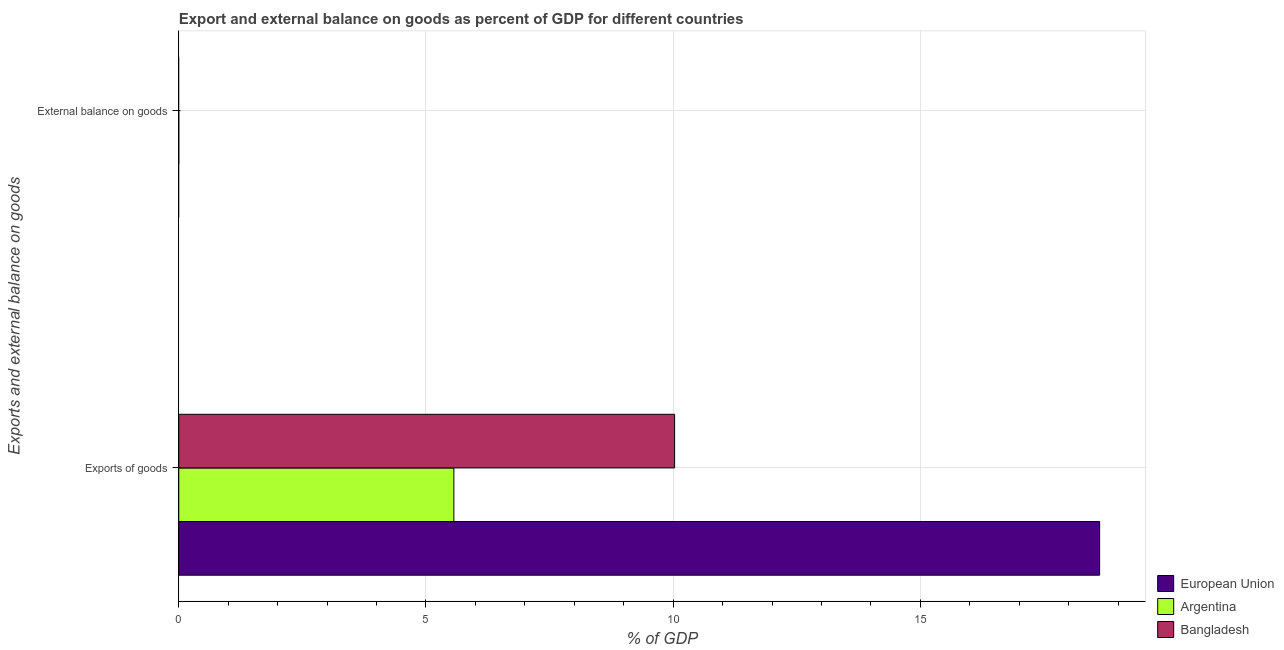How many different coloured bars are there?
Ensure brevity in your answer.  3. Are the number of bars per tick equal to the number of legend labels?
Your answer should be very brief. No. What is the label of the 2nd group of bars from the top?
Make the answer very short. Exports of goods. What is the export of goods as percentage of gdp in Argentina?
Offer a terse response. 5.56. Across all countries, what is the maximum external balance on goods as percentage of gdp?
Your answer should be compact. 1.53002140132025e-6. In which country was the export of goods as percentage of gdp maximum?
Offer a terse response. European Union. What is the total export of goods as percentage of gdp in the graph?
Make the answer very short. 34.22. What is the difference between the export of goods as percentage of gdp in Bangladesh and that in European Union?
Your answer should be compact. -8.6. What is the difference between the export of goods as percentage of gdp in Bangladesh and the external balance on goods as percentage of gdp in European Union?
Make the answer very short. 10.03. What is the average export of goods as percentage of gdp per country?
Your answer should be compact. 11.41. What is the difference between the export of goods as percentage of gdp and external balance on goods as percentage of gdp in Argentina?
Offer a terse response. 5.56. In how many countries, is the export of goods as percentage of gdp greater than 14 %?
Your response must be concise. 1. Is the export of goods as percentage of gdp in European Union less than that in Bangladesh?
Make the answer very short. No. In how many countries, is the export of goods as percentage of gdp greater than the average export of goods as percentage of gdp taken over all countries?
Your response must be concise. 1. How many countries are there in the graph?
Keep it short and to the point. 3. Are the values on the major ticks of X-axis written in scientific E-notation?
Give a very brief answer. No. Does the graph contain any zero values?
Offer a terse response. Yes. How many legend labels are there?
Offer a very short reply. 3. How are the legend labels stacked?
Provide a short and direct response. Vertical. What is the title of the graph?
Provide a succinct answer. Export and external balance on goods as percent of GDP for different countries. What is the label or title of the X-axis?
Ensure brevity in your answer.  % of GDP. What is the label or title of the Y-axis?
Your response must be concise. Exports and external balance on goods. What is the % of GDP of European Union in Exports of goods?
Ensure brevity in your answer.  18.62. What is the % of GDP in Argentina in Exports of goods?
Your response must be concise. 5.56. What is the % of GDP of Bangladesh in Exports of goods?
Offer a very short reply. 10.03. What is the % of GDP in European Union in External balance on goods?
Provide a succinct answer. 0. What is the % of GDP in Argentina in External balance on goods?
Your response must be concise. 1.53002140132025e-6. Across all Exports and external balance on goods, what is the maximum % of GDP of European Union?
Offer a very short reply. 18.62. Across all Exports and external balance on goods, what is the maximum % of GDP of Argentina?
Offer a very short reply. 5.56. Across all Exports and external balance on goods, what is the maximum % of GDP of Bangladesh?
Ensure brevity in your answer.  10.03. Across all Exports and external balance on goods, what is the minimum % of GDP of Argentina?
Make the answer very short. 1.53002140132025e-6. What is the total % of GDP in European Union in the graph?
Offer a terse response. 18.62. What is the total % of GDP in Argentina in the graph?
Ensure brevity in your answer.  5.56. What is the total % of GDP in Bangladesh in the graph?
Provide a succinct answer. 10.03. What is the difference between the % of GDP in Argentina in Exports of goods and that in External balance on goods?
Your response must be concise. 5.56. What is the difference between the % of GDP of European Union in Exports of goods and the % of GDP of Argentina in External balance on goods?
Ensure brevity in your answer.  18.62. What is the average % of GDP of European Union per Exports and external balance on goods?
Offer a terse response. 9.31. What is the average % of GDP in Argentina per Exports and external balance on goods?
Your response must be concise. 2.78. What is the average % of GDP of Bangladesh per Exports and external balance on goods?
Give a very brief answer. 5.01. What is the difference between the % of GDP of European Union and % of GDP of Argentina in Exports of goods?
Provide a short and direct response. 13.06. What is the difference between the % of GDP of European Union and % of GDP of Bangladesh in Exports of goods?
Make the answer very short. 8.6. What is the difference between the % of GDP in Argentina and % of GDP in Bangladesh in Exports of goods?
Give a very brief answer. -4.46. What is the ratio of the % of GDP in Argentina in Exports of goods to that in External balance on goods?
Provide a succinct answer. 3.64e+06. What is the difference between the highest and the second highest % of GDP of Argentina?
Offer a terse response. 5.56. What is the difference between the highest and the lowest % of GDP in European Union?
Provide a succinct answer. 18.62. What is the difference between the highest and the lowest % of GDP of Argentina?
Your answer should be compact. 5.56. What is the difference between the highest and the lowest % of GDP of Bangladesh?
Offer a terse response. 10.03. 